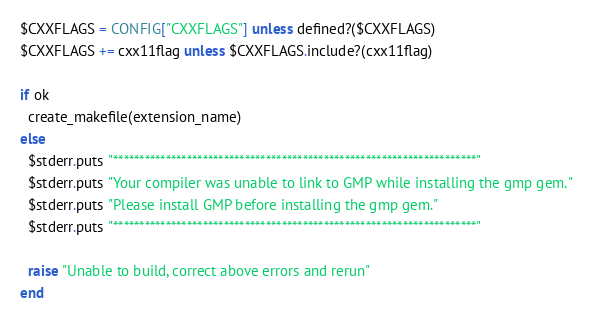Convert code to text. <code><loc_0><loc_0><loc_500><loc_500><_Ruby_>$CXXFLAGS = CONFIG["CXXFLAGS"] unless defined?($CXXFLAGS)
$CXXFLAGS += cxx11flag unless $CXXFLAGS.include?(cxx11flag)

if ok
  create_makefile(extension_name)
else
  $stderr.puts "*********************************************************************"
  $stderr.puts "Your compiler was unable to link to GMP while installing the gmp gem."
  $stderr.puts "Please install GMP before installing the gmp gem."
  $stderr.puts "*********************************************************************"

  raise "Unable to build, correct above errors and rerun"
end

</code> 